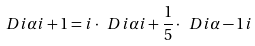Convert formula to latex. <formula><loc_0><loc_0><loc_500><loc_500>\ D i { \alpha } { i + 1 } = i \cdot \ D i { \alpha } { i } + \frac { 1 } { 5 } \cdot \ D i { \alpha - 1 } { i }</formula> 